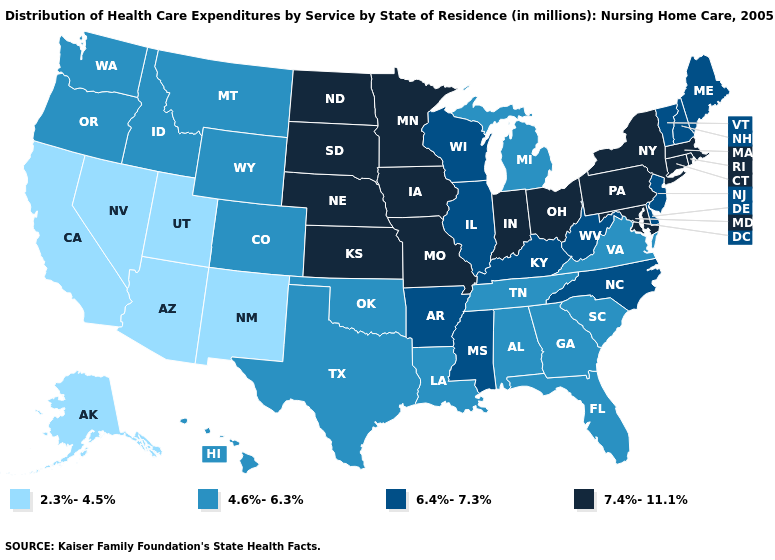Does Alaska have the same value as Utah?
Write a very short answer. Yes. What is the lowest value in the USA?
Keep it brief. 2.3%-4.5%. Name the states that have a value in the range 7.4%-11.1%?
Give a very brief answer. Connecticut, Indiana, Iowa, Kansas, Maryland, Massachusetts, Minnesota, Missouri, Nebraska, New York, North Dakota, Ohio, Pennsylvania, Rhode Island, South Dakota. Name the states that have a value in the range 7.4%-11.1%?
Concise answer only. Connecticut, Indiana, Iowa, Kansas, Maryland, Massachusetts, Minnesota, Missouri, Nebraska, New York, North Dakota, Ohio, Pennsylvania, Rhode Island, South Dakota. Which states have the lowest value in the MidWest?
Answer briefly. Michigan. Does Tennessee have the lowest value in the USA?
Short answer required. No. What is the lowest value in the Northeast?
Be succinct. 6.4%-7.3%. What is the value of Oklahoma?
Write a very short answer. 4.6%-6.3%. Does Nebraska have the highest value in the MidWest?
Answer briefly. Yes. Which states have the lowest value in the USA?
Concise answer only. Alaska, Arizona, California, Nevada, New Mexico, Utah. Does Wisconsin have the highest value in the USA?
Be succinct. No. What is the value of Michigan?
Answer briefly. 4.6%-6.3%. Is the legend a continuous bar?
Be succinct. No. What is the value of Connecticut?
Keep it brief. 7.4%-11.1%. 